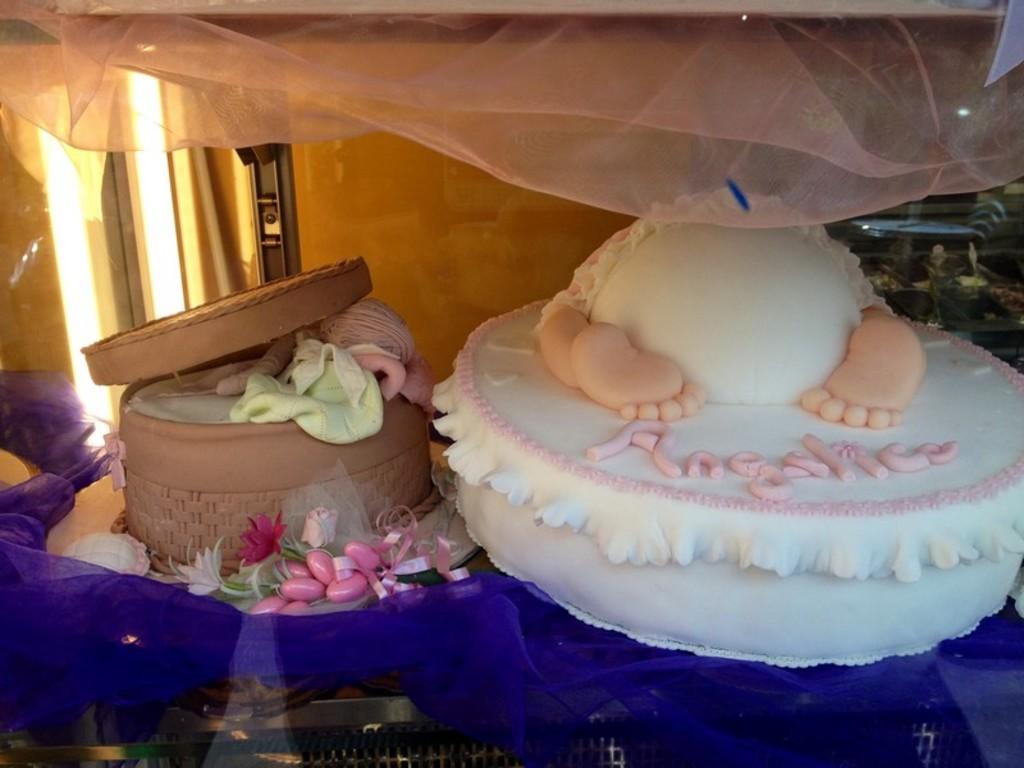Could you give a brief overview of what you see in this image? In this picture we can see there are cakes on an object and behind the cakes there is a wall and other things. 